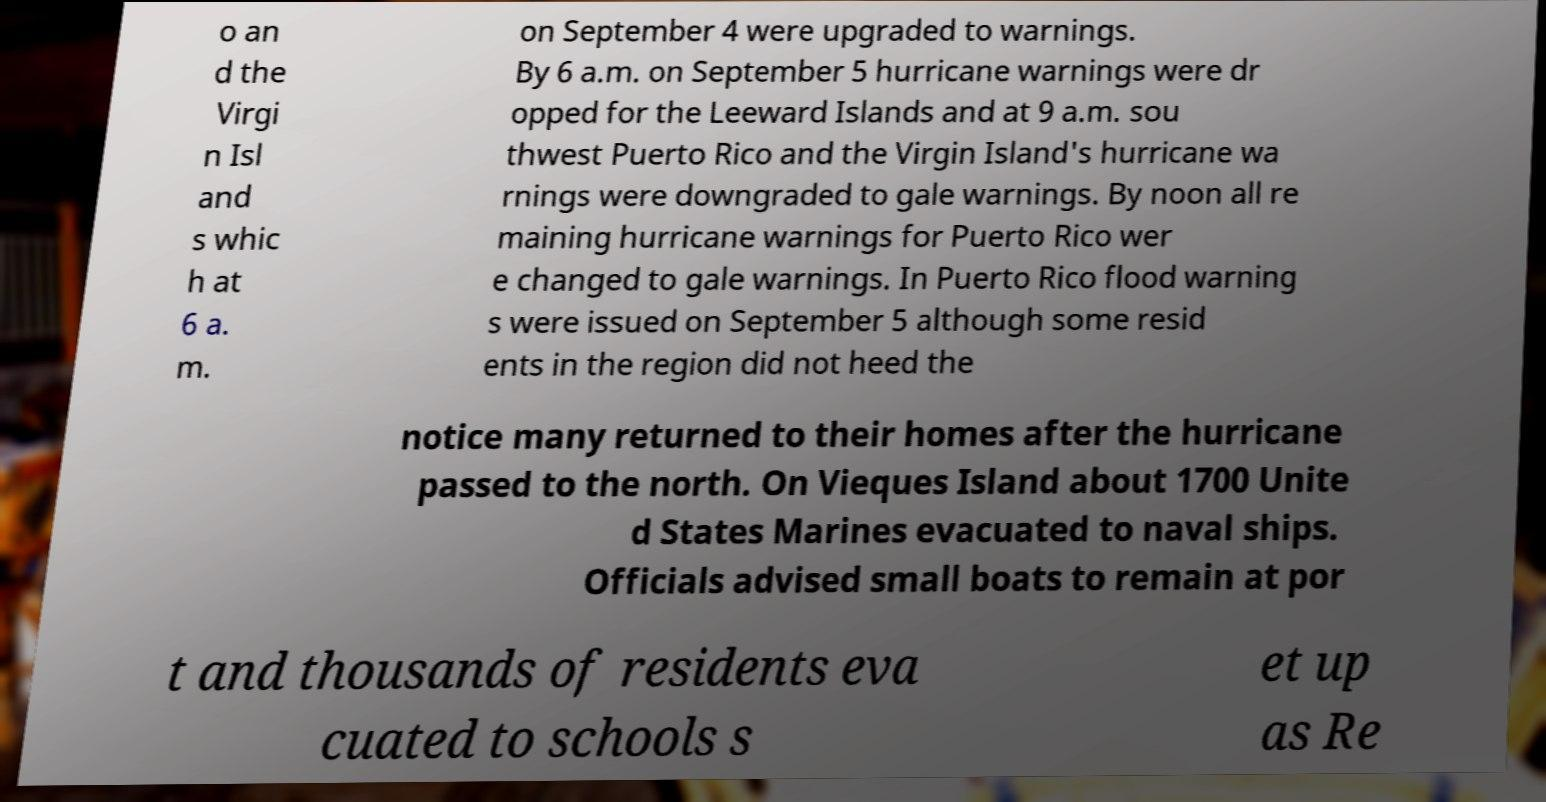Can you read and provide the text displayed in the image?This photo seems to have some interesting text. Can you extract and type it out for me? o an d the Virgi n Isl and s whic h at 6 a. m. on September 4 were upgraded to warnings. By 6 a.m. on September 5 hurricane warnings were dr opped for the Leeward Islands and at 9 a.m. sou thwest Puerto Rico and the Virgin Island's hurricane wa rnings were downgraded to gale warnings. By noon all re maining hurricane warnings for Puerto Rico wer e changed to gale warnings. In Puerto Rico flood warning s were issued on September 5 although some resid ents in the region did not heed the notice many returned to their homes after the hurricane passed to the north. On Vieques Island about 1700 Unite d States Marines evacuated to naval ships. Officials advised small boats to remain at por t and thousands of residents eva cuated to schools s et up as Re 